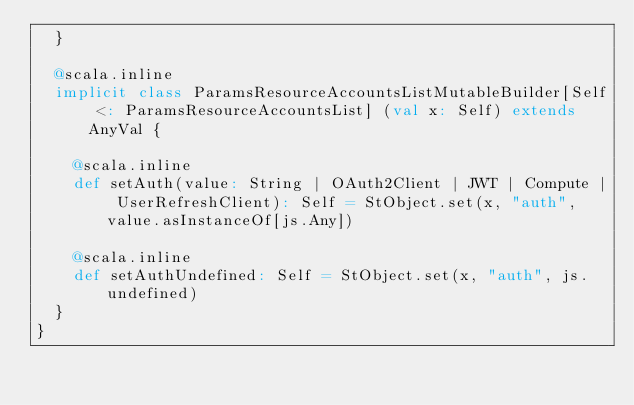Convert code to text. <code><loc_0><loc_0><loc_500><loc_500><_Scala_>  }
  
  @scala.inline
  implicit class ParamsResourceAccountsListMutableBuilder[Self <: ParamsResourceAccountsList] (val x: Self) extends AnyVal {
    
    @scala.inline
    def setAuth(value: String | OAuth2Client | JWT | Compute | UserRefreshClient): Self = StObject.set(x, "auth", value.asInstanceOf[js.Any])
    
    @scala.inline
    def setAuthUndefined: Self = StObject.set(x, "auth", js.undefined)
  }
}
</code> 